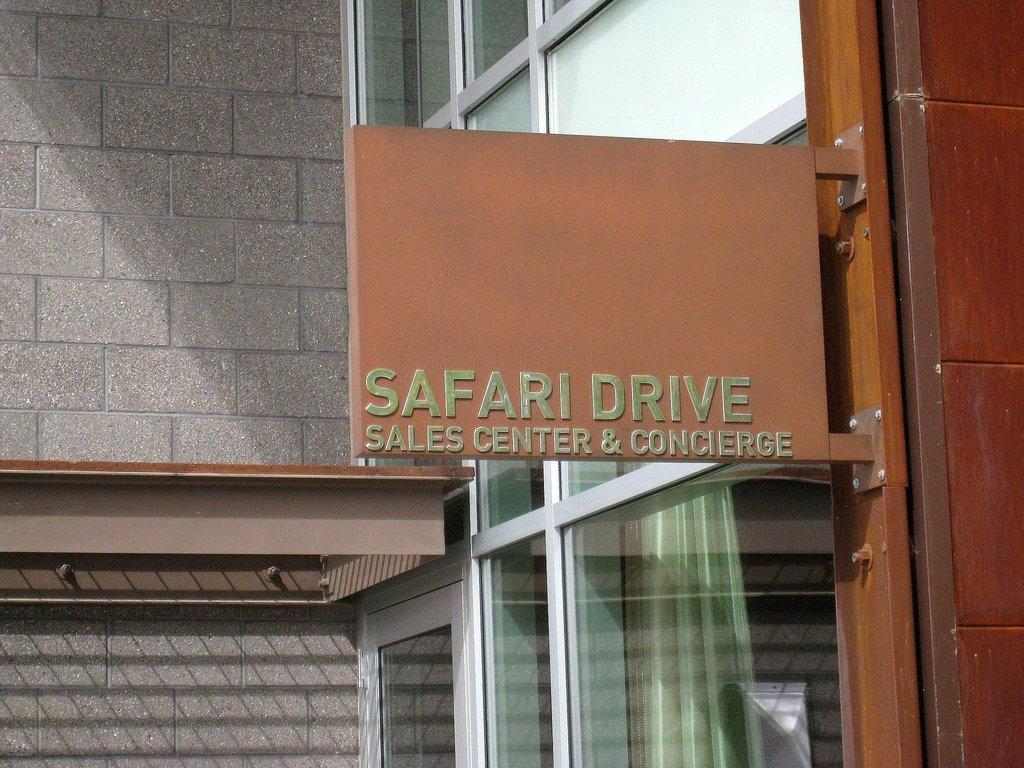What is attached to a rod in the image? There is a name board attached to a rod in the image. What can be seen behind the name board? There is a wall visible in the image. What material is present in the image that allows for transparency? There is glass in the image. What is visible through the glass? A curtain is visible through the glass. What type of hat is being printed on the wall in the image? There is no hat or printing visible on the wall in the image. 